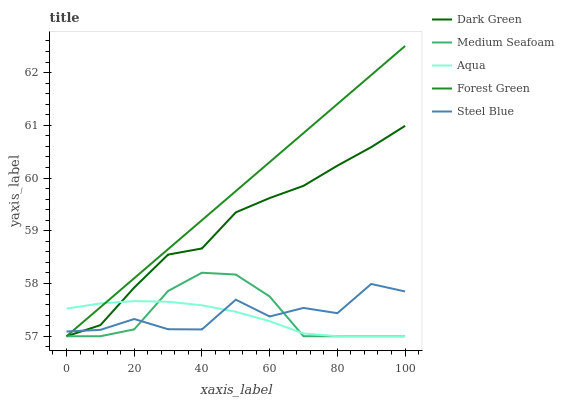Does Aqua have the minimum area under the curve?
Answer yes or no. Yes. Does Forest Green have the maximum area under the curve?
Answer yes or no. Yes. Does Medium Seafoam have the minimum area under the curve?
Answer yes or no. No. Does Medium Seafoam have the maximum area under the curve?
Answer yes or no. No. Is Forest Green the smoothest?
Answer yes or no. Yes. Is Steel Blue the roughest?
Answer yes or no. Yes. Is Aqua the smoothest?
Answer yes or no. No. Is Aqua the roughest?
Answer yes or no. No. Does Forest Green have the lowest value?
Answer yes or no. Yes. Does Steel Blue have the lowest value?
Answer yes or no. No. Does Forest Green have the highest value?
Answer yes or no. Yes. Does Medium Seafoam have the highest value?
Answer yes or no. No. Does Aqua intersect Steel Blue?
Answer yes or no. Yes. Is Aqua less than Steel Blue?
Answer yes or no. No. Is Aqua greater than Steel Blue?
Answer yes or no. No. 